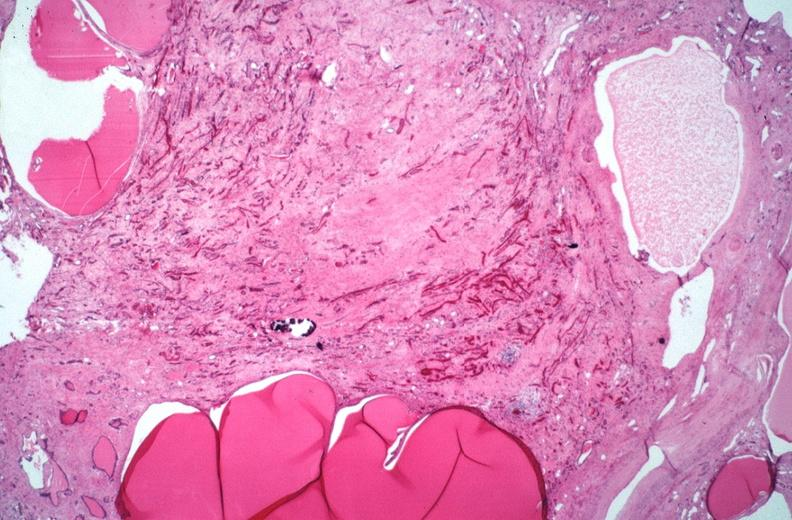does sle v. urinary show kidney, adult polycystic kidney?
Answer the question using a single word or phrase. No 